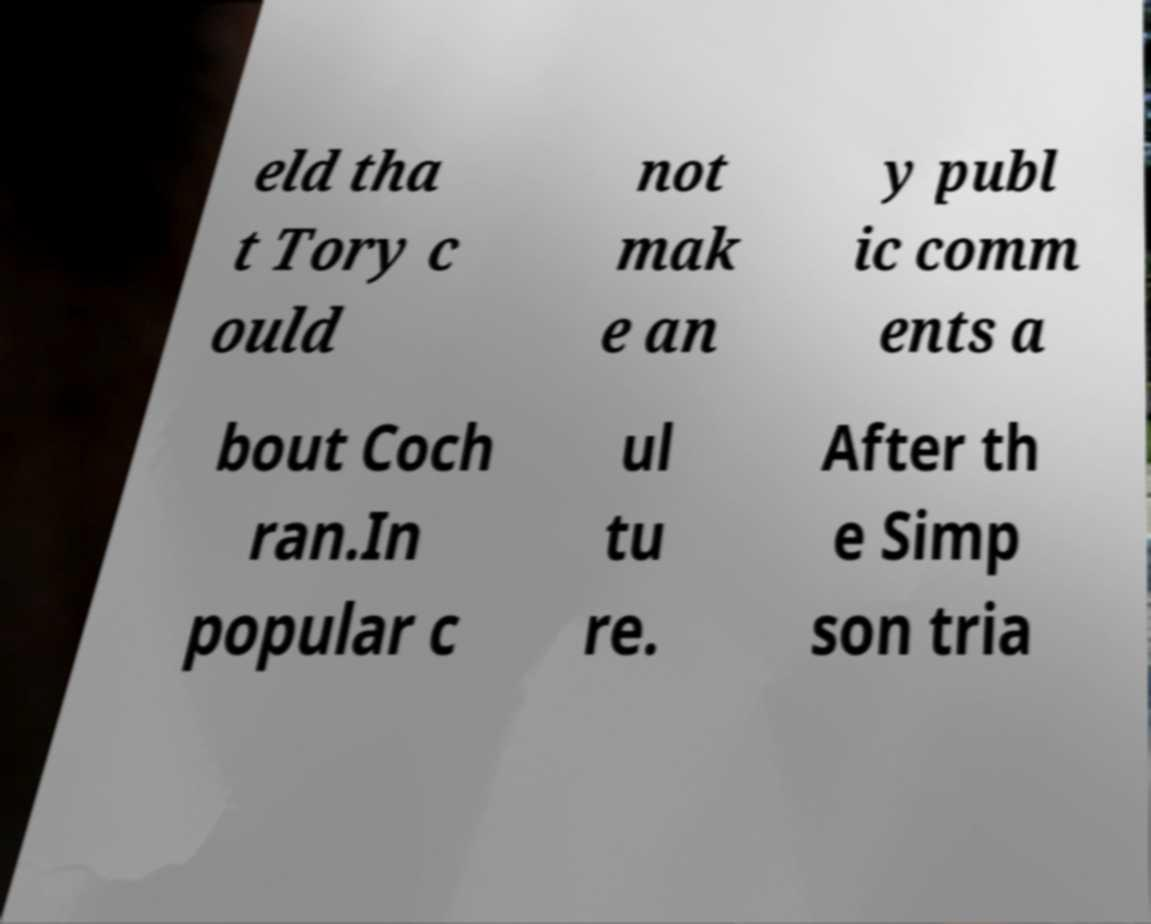Please identify and transcribe the text found in this image. eld tha t Tory c ould not mak e an y publ ic comm ents a bout Coch ran.In popular c ul tu re. After th e Simp son tria 